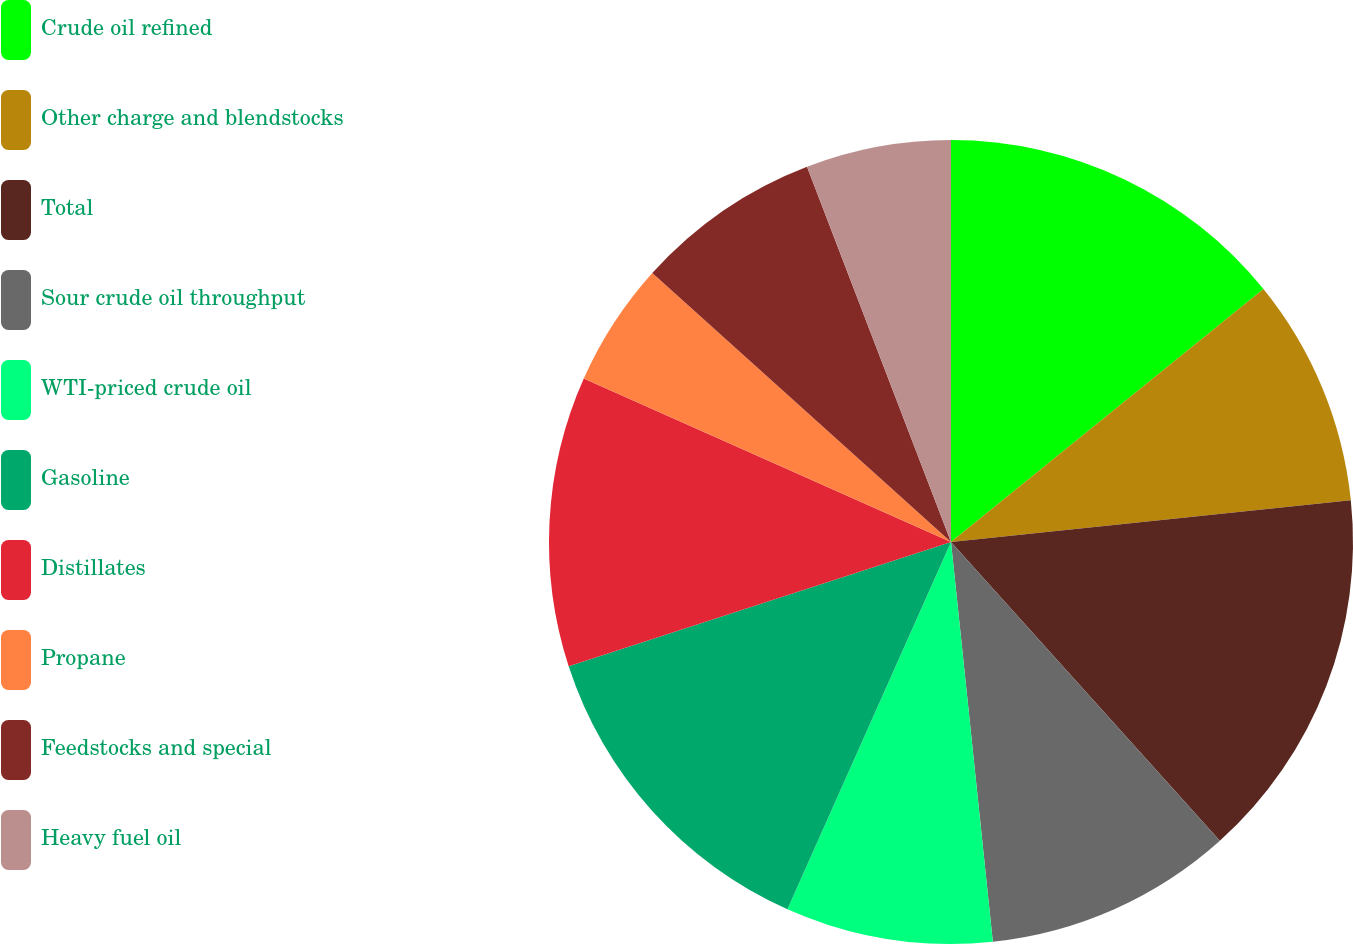<chart> <loc_0><loc_0><loc_500><loc_500><pie_chart><fcel>Crude oil refined<fcel>Other charge and blendstocks<fcel>Total<fcel>Sour crude oil throughput<fcel>WTI-priced crude oil<fcel>Gasoline<fcel>Distillates<fcel>Propane<fcel>Feedstocks and special<fcel>Heavy fuel oil<nl><fcel>14.17%<fcel>9.17%<fcel>15.0%<fcel>10.0%<fcel>8.33%<fcel>13.33%<fcel>11.67%<fcel>5.0%<fcel>7.5%<fcel>5.83%<nl></chart> 